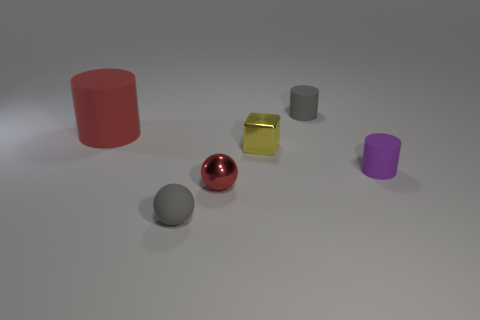Subtract all cyan spheres. Subtract all yellow cylinders. How many spheres are left? 2 Add 1 rubber objects. How many objects exist? 7 Subtract all cubes. How many objects are left? 5 Subtract 0 cyan cylinders. How many objects are left? 6 Subtract all gray cylinders. Subtract all cubes. How many objects are left? 4 Add 6 metal objects. How many metal objects are left? 8 Add 5 cyan things. How many cyan things exist? 5 